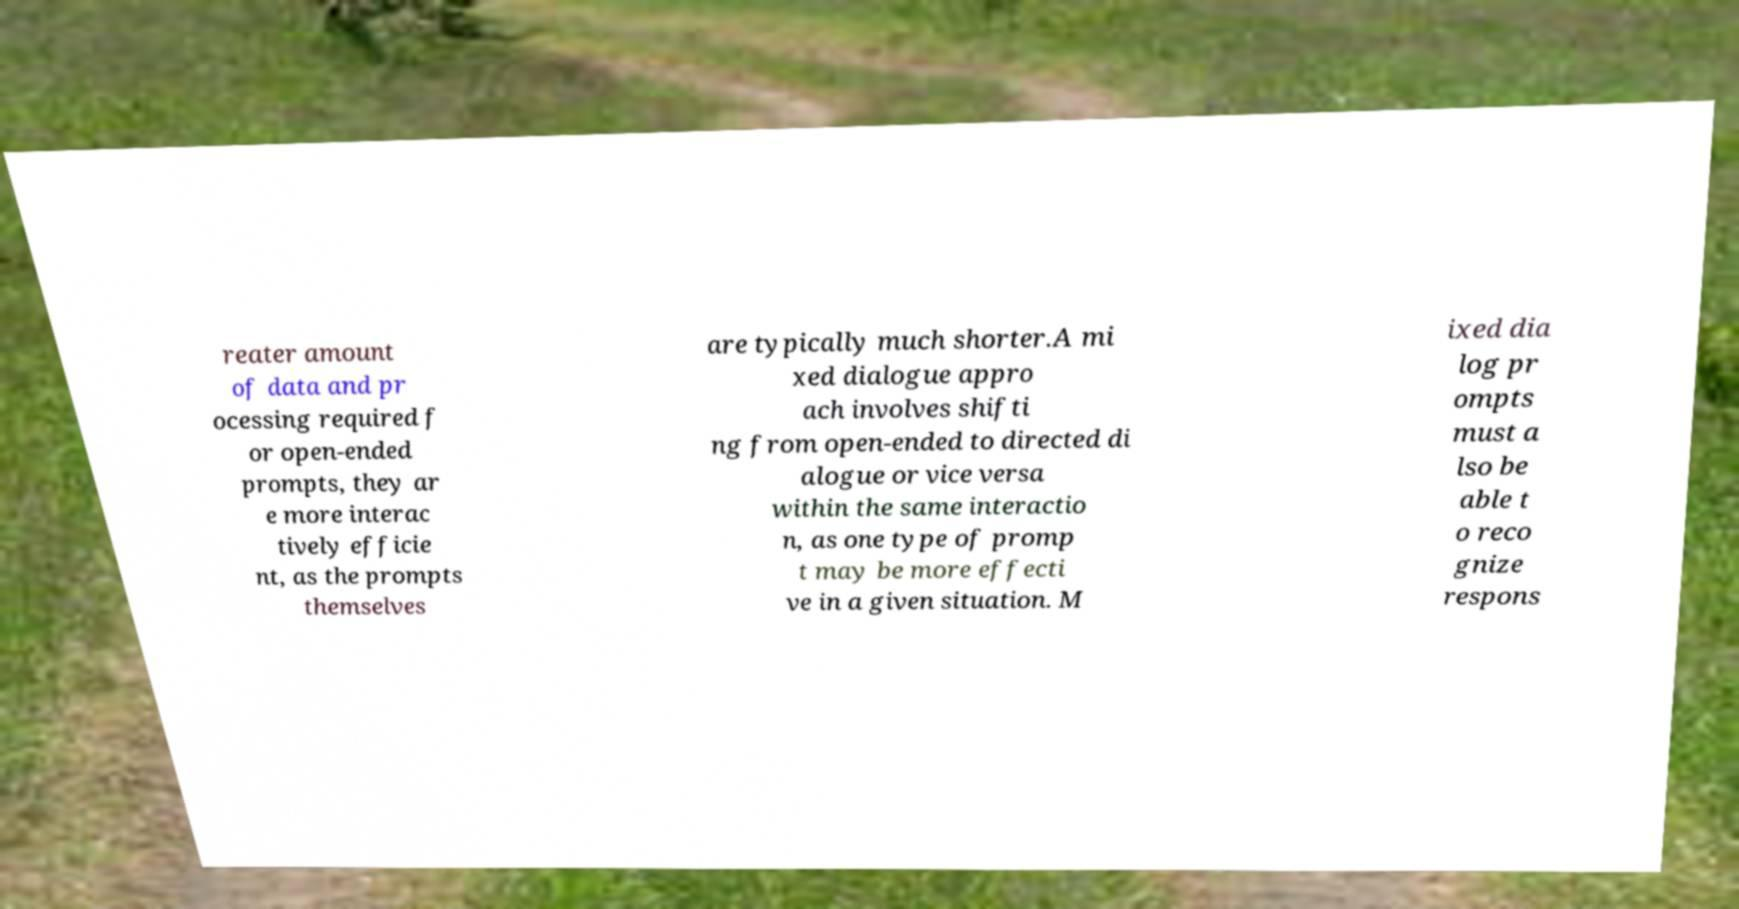Can you accurately transcribe the text from the provided image for me? reater amount of data and pr ocessing required f or open-ended prompts, they ar e more interac tively efficie nt, as the prompts themselves are typically much shorter.A mi xed dialogue appro ach involves shifti ng from open-ended to directed di alogue or vice versa within the same interactio n, as one type of promp t may be more effecti ve in a given situation. M ixed dia log pr ompts must a lso be able t o reco gnize respons 